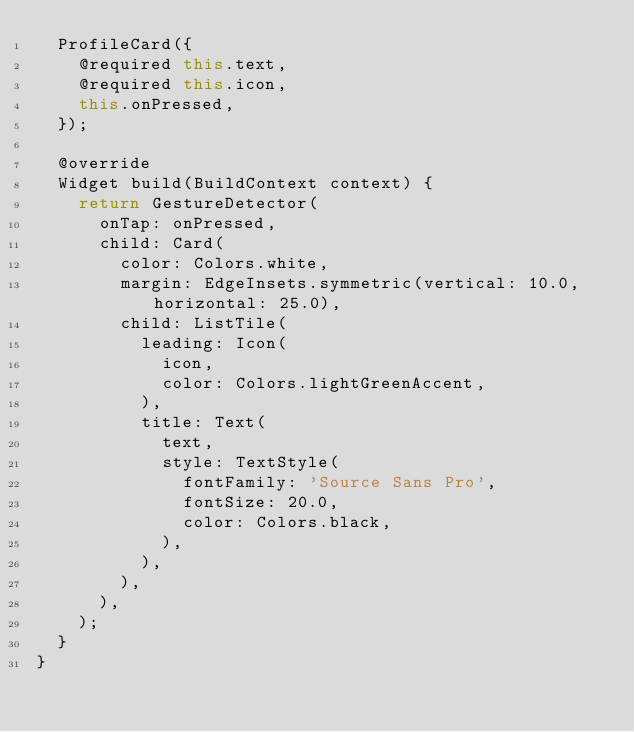<code> <loc_0><loc_0><loc_500><loc_500><_Dart_>  ProfileCard({
    @required this.text,
    @required this.icon,
    this.onPressed,
  });

  @override
  Widget build(BuildContext context) {
    return GestureDetector(
      onTap: onPressed,
      child: Card(
        color: Colors.white,
        margin: EdgeInsets.symmetric(vertical: 10.0, horizontal: 25.0),
        child: ListTile(
          leading: Icon(
            icon,
            color: Colors.lightGreenAccent,
          ),
          title: Text(
            text,
            style: TextStyle(
              fontFamily: 'Source Sans Pro',
              fontSize: 20.0,
              color: Colors.black,
            ),
          ),
        ),
      ),
    );
  }
}
</code> 